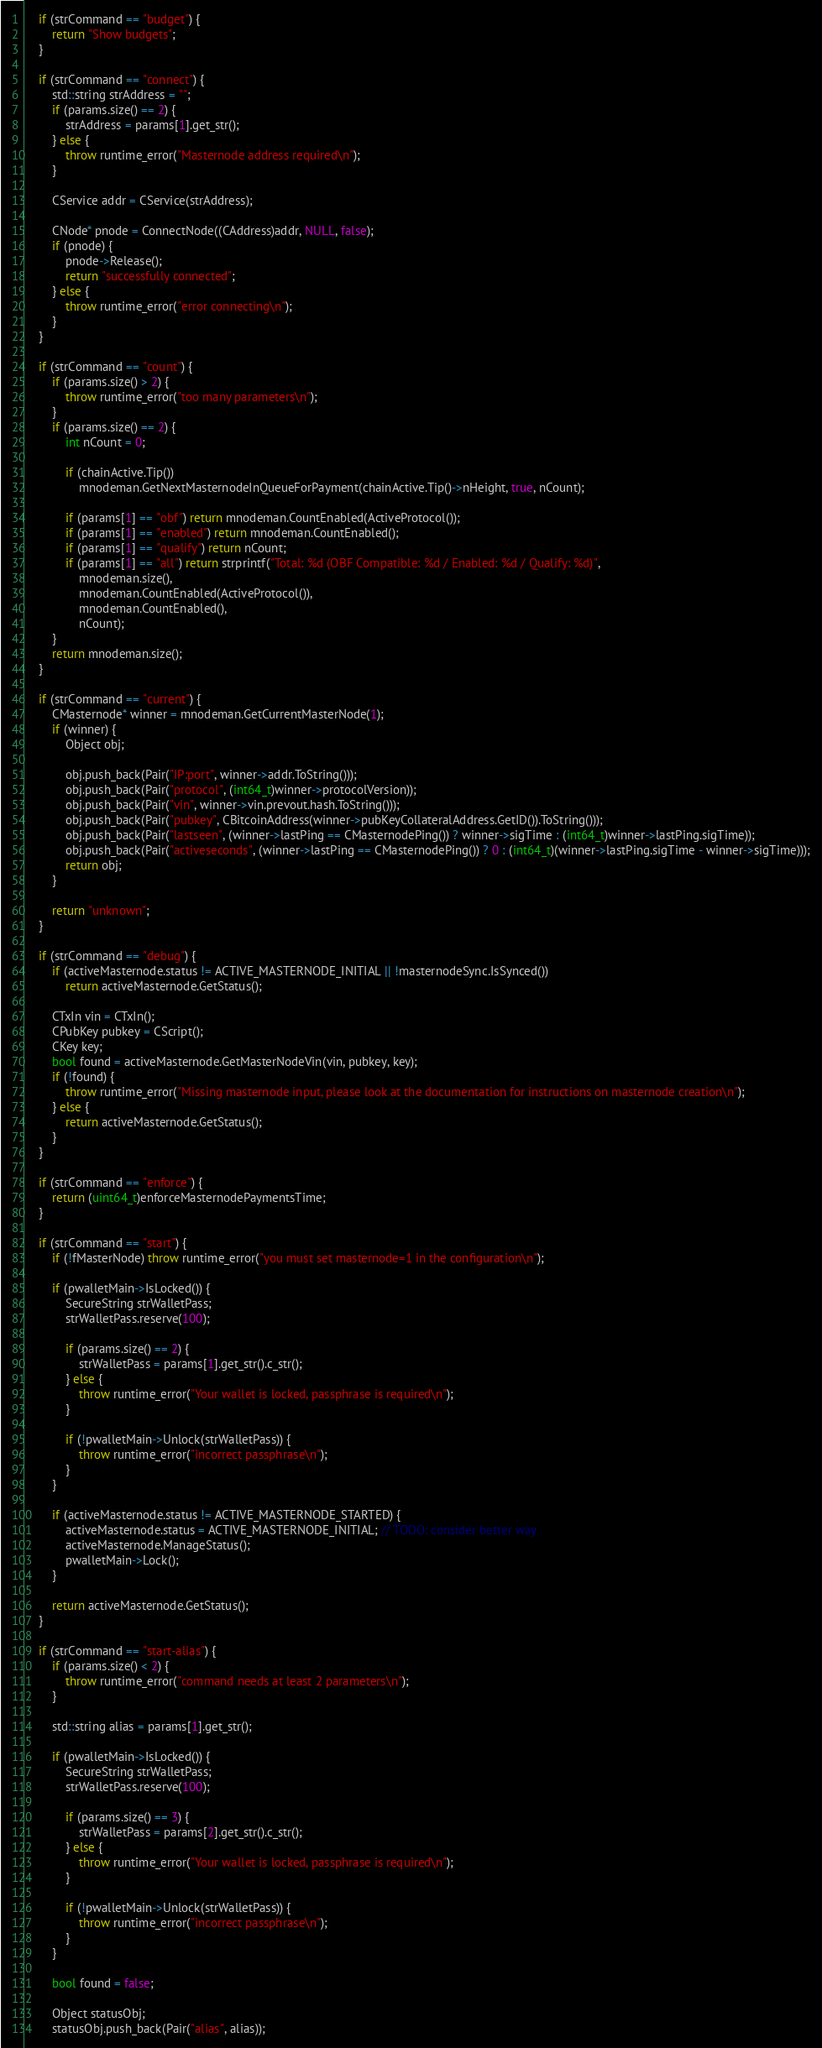Convert code to text. <code><loc_0><loc_0><loc_500><loc_500><_C++_>    if (strCommand == "budget") {
        return "Show budgets";
    }

    if (strCommand == "connect") {
        std::string strAddress = "";
        if (params.size() == 2) {
            strAddress = params[1].get_str();
        } else {
            throw runtime_error("Masternode address required\n");
        }

        CService addr = CService(strAddress);

        CNode* pnode = ConnectNode((CAddress)addr, NULL, false);
        if (pnode) {
            pnode->Release();
            return "successfully connected";
        } else {
            throw runtime_error("error connecting\n");
        }
    }

    if (strCommand == "count") {
        if (params.size() > 2) {
            throw runtime_error("too many parameters\n");
        }
        if (params.size() == 2) {
            int nCount = 0;

            if (chainActive.Tip())
                mnodeman.GetNextMasternodeInQueueForPayment(chainActive.Tip()->nHeight, true, nCount);

            if (params[1] == "obf") return mnodeman.CountEnabled(ActiveProtocol());
            if (params[1] == "enabled") return mnodeman.CountEnabled();
            if (params[1] == "qualify") return nCount;
            if (params[1] == "all") return strprintf("Total: %d (OBF Compatible: %d / Enabled: %d / Qualify: %d)",
                mnodeman.size(),
                mnodeman.CountEnabled(ActiveProtocol()),
                mnodeman.CountEnabled(),
                nCount);
        }
        return mnodeman.size();
    }

    if (strCommand == "current") {
        CMasternode* winner = mnodeman.GetCurrentMasterNode(1);
        if (winner) {
            Object obj;

            obj.push_back(Pair("IP:port", winner->addr.ToString()));
            obj.push_back(Pair("protocol", (int64_t)winner->protocolVersion));
            obj.push_back(Pair("vin", winner->vin.prevout.hash.ToString()));
            obj.push_back(Pair("pubkey", CBitcoinAddress(winner->pubKeyCollateralAddress.GetID()).ToString()));
            obj.push_back(Pair("lastseen", (winner->lastPing == CMasternodePing()) ? winner->sigTime : (int64_t)winner->lastPing.sigTime));
            obj.push_back(Pair("activeseconds", (winner->lastPing == CMasternodePing()) ? 0 : (int64_t)(winner->lastPing.sigTime - winner->sigTime)));
            return obj;
        }

        return "unknown";
    }

    if (strCommand == "debug") {
        if (activeMasternode.status != ACTIVE_MASTERNODE_INITIAL || !masternodeSync.IsSynced())
            return activeMasternode.GetStatus();

        CTxIn vin = CTxIn();
        CPubKey pubkey = CScript();
        CKey key;
        bool found = activeMasternode.GetMasterNodeVin(vin, pubkey, key);
        if (!found) {
            throw runtime_error("Missing masternode input, please look at the documentation for instructions on masternode creation\n");
        } else {
            return activeMasternode.GetStatus();
        }
    }

    if (strCommand == "enforce") {
        return (uint64_t)enforceMasternodePaymentsTime;
    }

    if (strCommand == "start") {
        if (!fMasterNode) throw runtime_error("you must set masternode=1 in the configuration\n");

        if (pwalletMain->IsLocked()) {
            SecureString strWalletPass;
            strWalletPass.reserve(100);

            if (params.size() == 2) {
                strWalletPass = params[1].get_str().c_str();
            } else {
                throw runtime_error("Your wallet is locked, passphrase is required\n");
            }

            if (!pwalletMain->Unlock(strWalletPass)) {
                throw runtime_error("incorrect passphrase\n");
            }
        }

        if (activeMasternode.status != ACTIVE_MASTERNODE_STARTED) {
            activeMasternode.status = ACTIVE_MASTERNODE_INITIAL; // TODO: consider better way
            activeMasternode.ManageStatus();
            pwalletMain->Lock();
        }

        return activeMasternode.GetStatus();
    }

    if (strCommand == "start-alias") {
        if (params.size() < 2) {
            throw runtime_error("command needs at least 2 parameters\n");
        }

        std::string alias = params[1].get_str();

        if (pwalletMain->IsLocked()) {
            SecureString strWalletPass;
            strWalletPass.reserve(100);

            if (params.size() == 3) {
                strWalletPass = params[2].get_str().c_str();
            } else {
                throw runtime_error("Your wallet is locked, passphrase is required\n");
            }

            if (!pwalletMain->Unlock(strWalletPass)) {
                throw runtime_error("incorrect passphrase\n");
            }
        }

        bool found = false;

        Object statusObj;
        statusObj.push_back(Pair("alias", alias));
</code> 